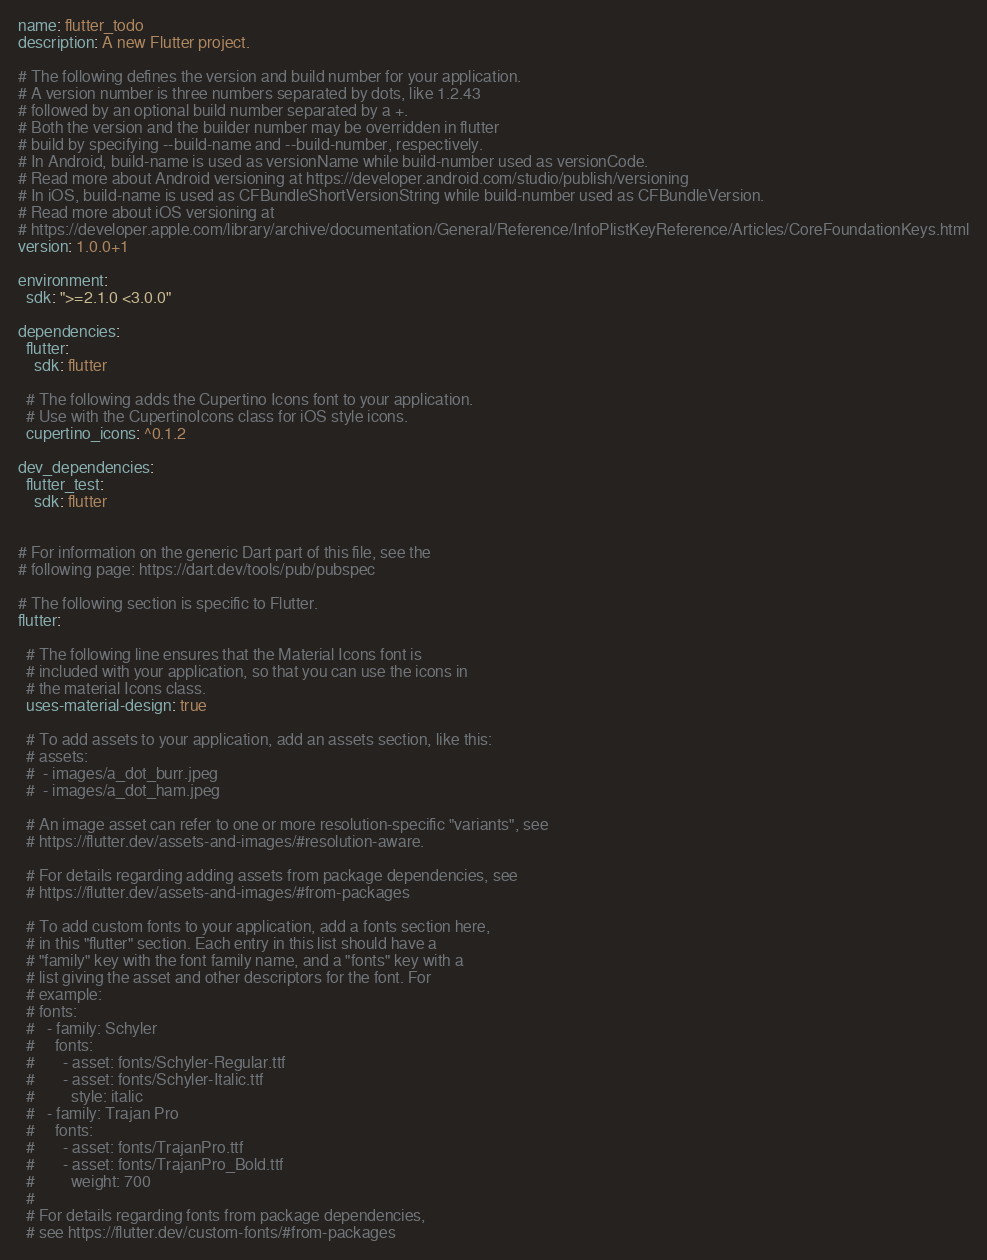Convert code to text. <code><loc_0><loc_0><loc_500><loc_500><_YAML_>name: flutter_todo
description: A new Flutter project.

# The following defines the version and build number for your application.
# A version number is three numbers separated by dots, like 1.2.43
# followed by an optional build number separated by a +.
# Both the version and the builder number may be overridden in flutter
# build by specifying --build-name and --build-number, respectively.
# In Android, build-name is used as versionName while build-number used as versionCode.
# Read more about Android versioning at https://developer.android.com/studio/publish/versioning
# In iOS, build-name is used as CFBundleShortVersionString while build-number used as CFBundleVersion.
# Read more about iOS versioning at
# https://developer.apple.com/library/archive/documentation/General/Reference/InfoPlistKeyReference/Articles/CoreFoundationKeys.html
version: 1.0.0+1

environment:
  sdk: ">=2.1.0 <3.0.0"

dependencies:
  flutter:
    sdk: flutter

  # The following adds the Cupertino Icons font to your application.
  # Use with the CupertinoIcons class for iOS style icons.
  cupertino_icons: ^0.1.2

dev_dependencies:
  flutter_test:
    sdk: flutter


# For information on the generic Dart part of this file, see the
# following page: https://dart.dev/tools/pub/pubspec

# The following section is specific to Flutter.
flutter:

  # The following line ensures that the Material Icons font is
  # included with your application, so that you can use the icons in
  # the material Icons class.
  uses-material-design: true

  # To add assets to your application, add an assets section, like this:
  # assets:
  #  - images/a_dot_burr.jpeg
  #  - images/a_dot_ham.jpeg

  # An image asset can refer to one or more resolution-specific "variants", see
  # https://flutter.dev/assets-and-images/#resolution-aware.

  # For details regarding adding assets from package dependencies, see
  # https://flutter.dev/assets-and-images/#from-packages

  # To add custom fonts to your application, add a fonts section here,
  # in this "flutter" section. Each entry in this list should have a
  # "family" key with the font family name, and a "fonts" key with a
  # list giving the asset and other descriptors for the font. For
  # example:
  # fonts:
  #   - family: Schyler
  #     fonts:
  #       - asset: fonts/Schyler-Regular.ttf
  #       - asset: fonts/Schyler-Italic.ttf
  #         style: italic
  #   - family: Trajan Pro
  #     fonts:
  #       - asset: fonts/TrajanPro.ttf
  #       - asset: fonts/TrajanPro_Bold.ttf
  #         weight: 700
  #
  # For details regarding fonts from package dependencies,
  # see https://flutter.dev/custom-fonts/#from-packages
</code> 